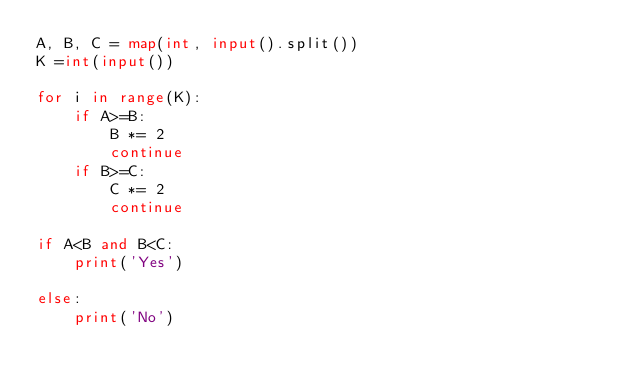Convert code to text. <code><loc_0><loc_0><loc_500><loc_500><_Python_>A, B, C = map(int, input().split())
K =int(input())

for i in range(K):
    if A>=B:
        B *= 2
        continue
    if B>=C:
        C *= 2
        continue

if A<B and B<C:
    print('Yes')

else:
    print('No')</code> 